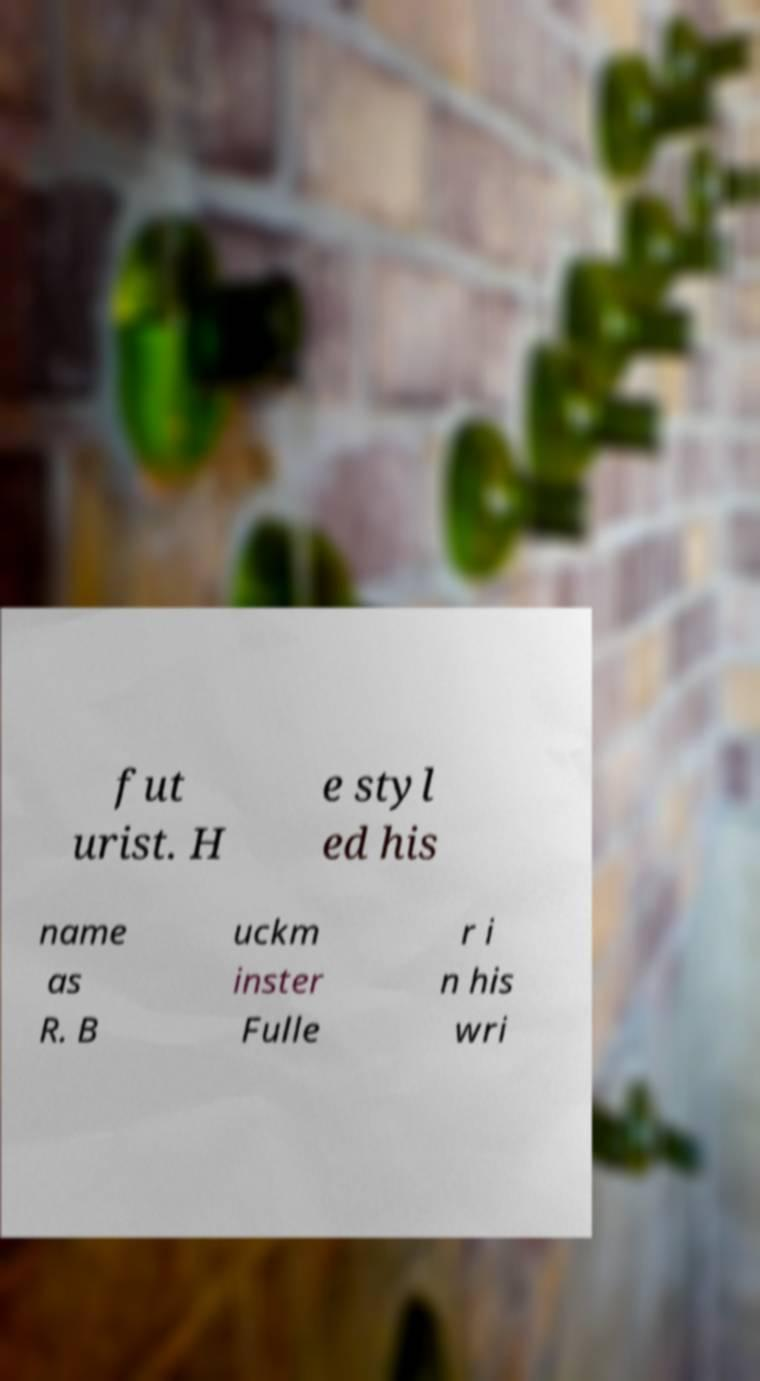Can you accurately transcribe the text from the provided image for me? fut urist. H e styl ed his name as R. B uckm inster Fulle r i n his wri 